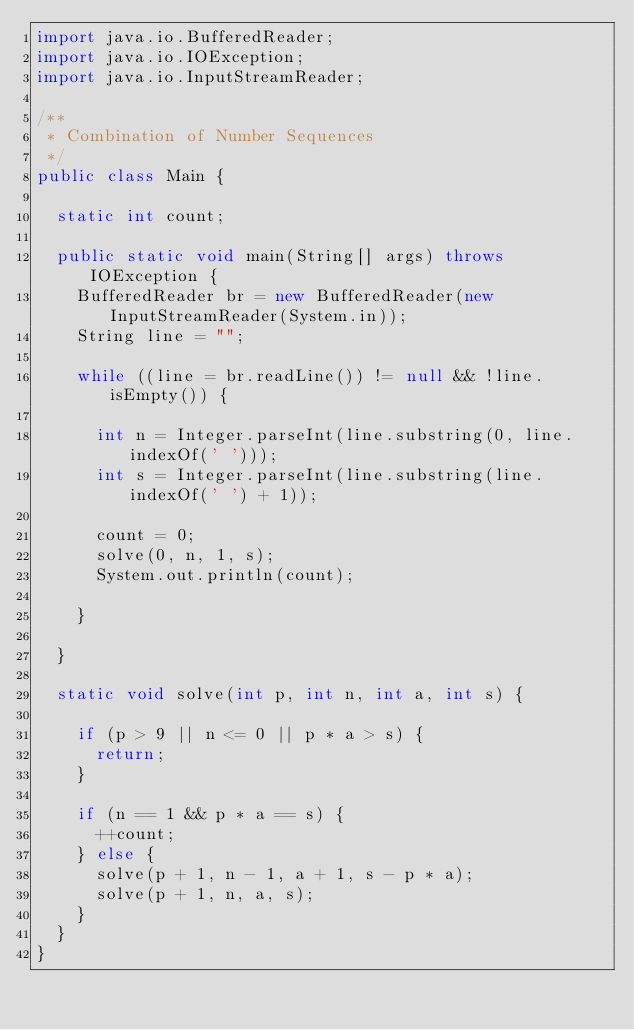<code> <loc_0><loc_0><loc_500><loc_500><_Java_>import java.io.BufferedReader;
import java.io.IOException;
import java.io.InputStreamReader;

/**
 * Combination of Number Sequences
 */
public class Main {

	static int count;

	public static void main(String[] args) throws IOException {
		BufferedReader br = new BufferedReader(new InputStreamReader(System.in));
		String line = "";

		while ((line = br.readLine()) != null && !line.isEmpty()) {

			int n = Integer.parseInt(line.substring(0, line.indexOf(' ')));
			int s = Integer.parseInt(line.substring(line.indexOf(' ') + 1));

			count = 0;
			solve(0, n, 1, s);
			System.out.println(count);

		}

	}

	static void solve(int p, int n, int a, int s) {

		if (p > 9 || n <= 0 || p * a > s) {
			return;
		}

		if (n == 1 && p * a == s) {
			++count;
		} else {
			solve(p + 1, n - 1, a + 1, s - p * a);
			solve(p + 1, n, a, s);
		}
	}
}</code> 